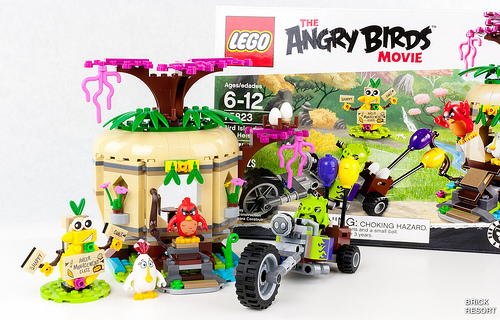<image>
Is the box on the motorcycle? No. The box is not positioned on the motorcycle. They may be near each other, but the box is not supported by or resting on top of the motorcycle. 